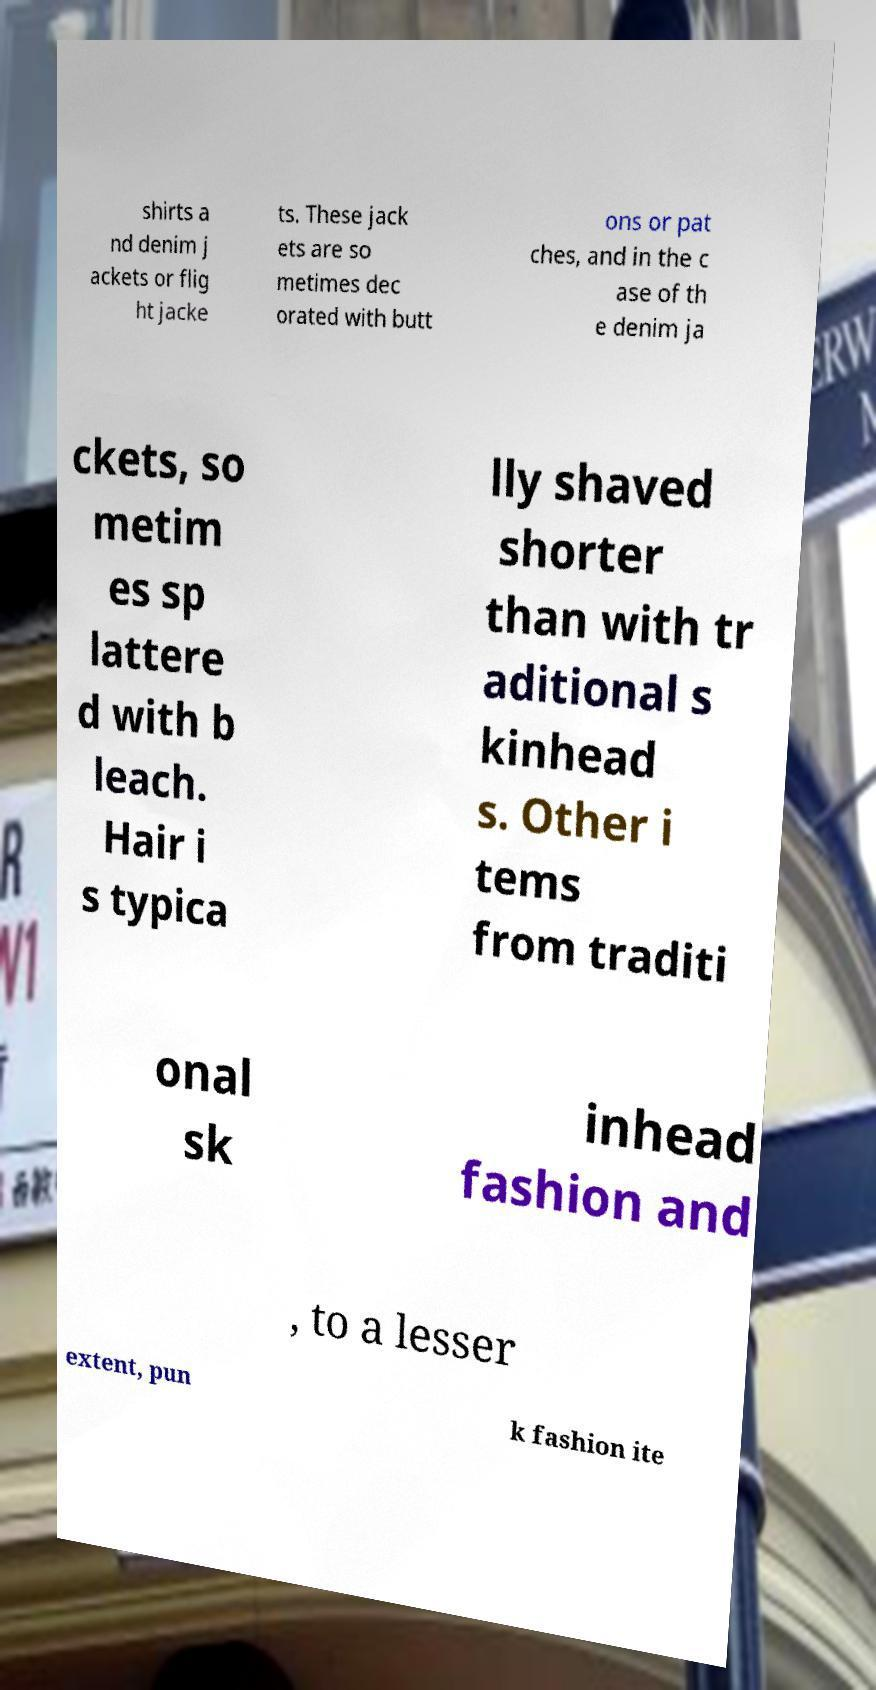I need the written content from this picture converted into text. Can you do that? shirts a nd denim j ackets or flig ht jacke ts. These jack ets are so metimes dec orated with butt ons or pat ches, and in the c ase of th e denim ja ckets, so metim es sp lattere d with b leach. Hair i s typica lly shaved shorter than with tr aditional s kinhead s. Other i tems from traditi onal sk inhead fashion and , to a lesser extent, pun k fashion ite 